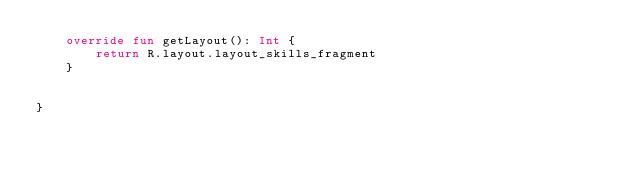<code> <loc_0><loc_0><loc_500><loc_500><_Kotlin_>    override fun getLayout(): Int {
        return R.layout.layout_skills_fragment
    }


}</code> 